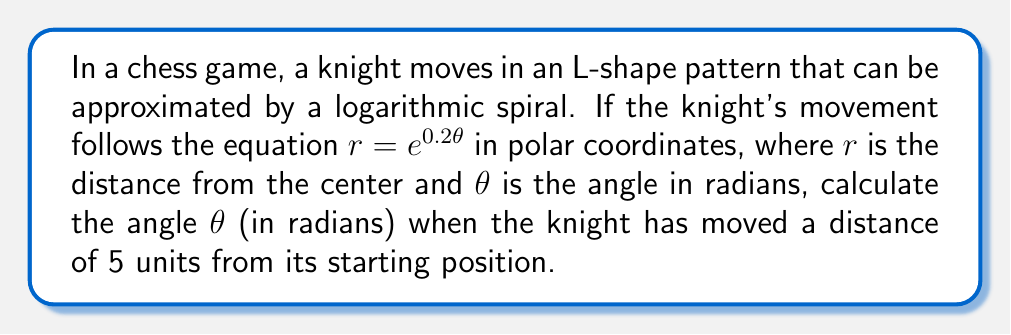Provide a solution to this math problem. To solve this problem, we'll use the given logarithmic spiral equation and follow these steps:

1) The equation of the logarithmic spiral is given as:
   $r = e^{0.2\theta}$

2) We're asked to find $\theta$ when $r = 5$. Let's substitute this into our equation:
   $5 = e^{0.2\theta}$

3) To isolate $\theta$, we need to take the natural logarithm of both sides:
   $\ln(5) = \ln(e^{0.2\theta})$

4) Using the property of logarithms that $\ln(e^x) = x$, we get:
   $\ln(5) = 0.2\theta$

5) Now we can solve for $\theta$ by dividing both sides by 0.2:
   $\theta = \frac{\ln(5)}{0.2}$

6) Calculate the final value:
   $\theta = \frac{\ln(5)}{0.2} \approx 8.0472$ radians

This angle represents the total angular displacement of the knight's movement along the logarithmic spiral when it reaches a distance of 5 units from its starting position.
Answer: $\frac{\ln(5)}{0.2}$ radians 